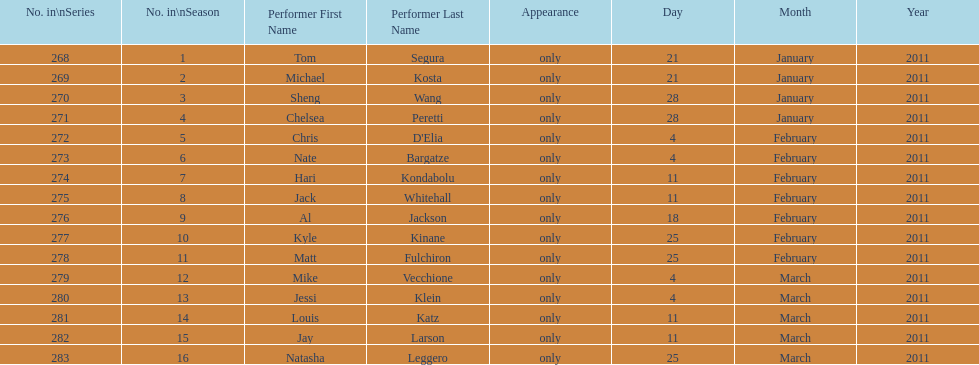How many different performers appeared during this season? 16. 